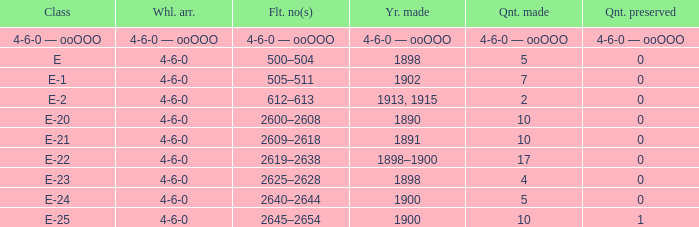How many e-22 class items are made when the preserved quantity is 0? 17.0. 